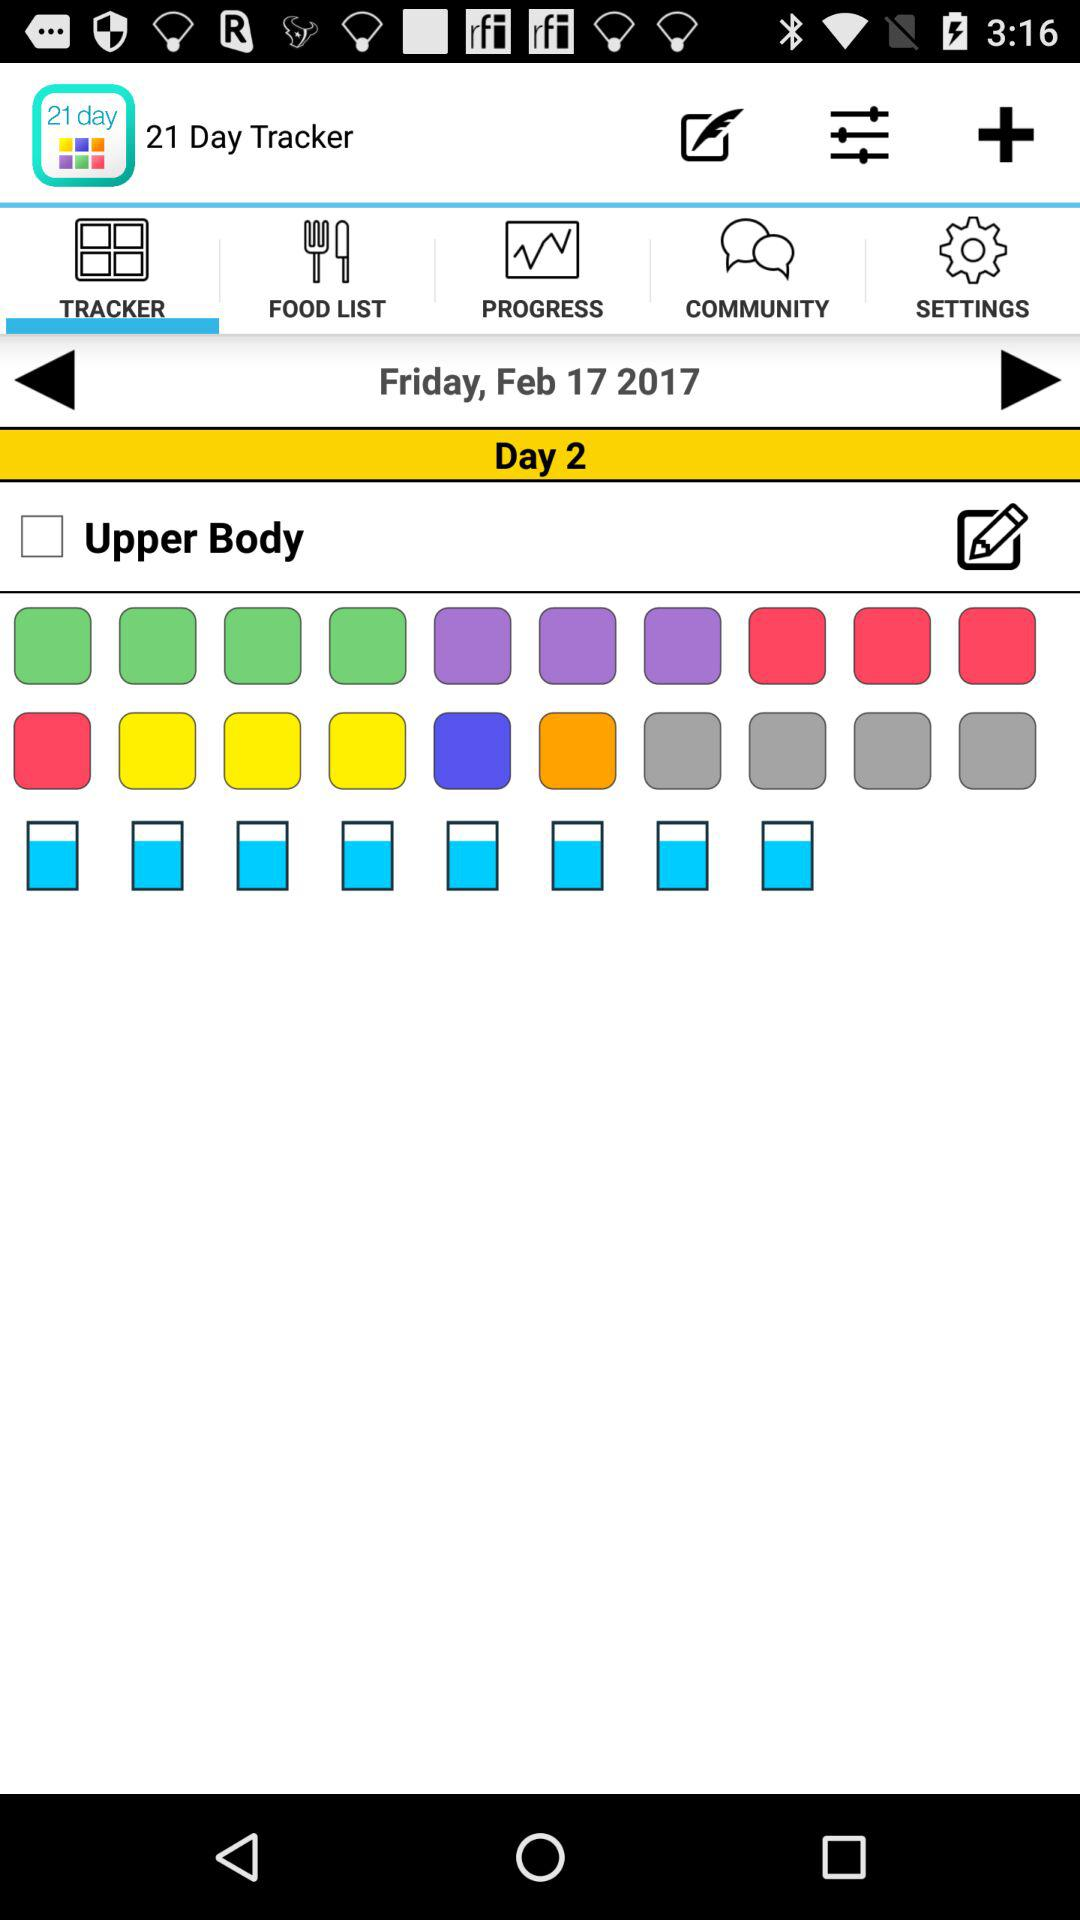What is the day and date? The day and date are Friday, February 17, 2017. 